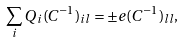<formula> <loc_0><loc_0><loc_500><loc_500>\sum _ { i } Q _ { i } ( C ^ { - 1 } ) _ { i l } = \pm e ( C ^ { - 1 } ) _ { l l } ,</formula> 